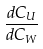Convert formula to latex. <formula><loc_0><loc_0><loc_500><loc_500>\frac { d C _ { U } } { d C _ { W } }</formula> 